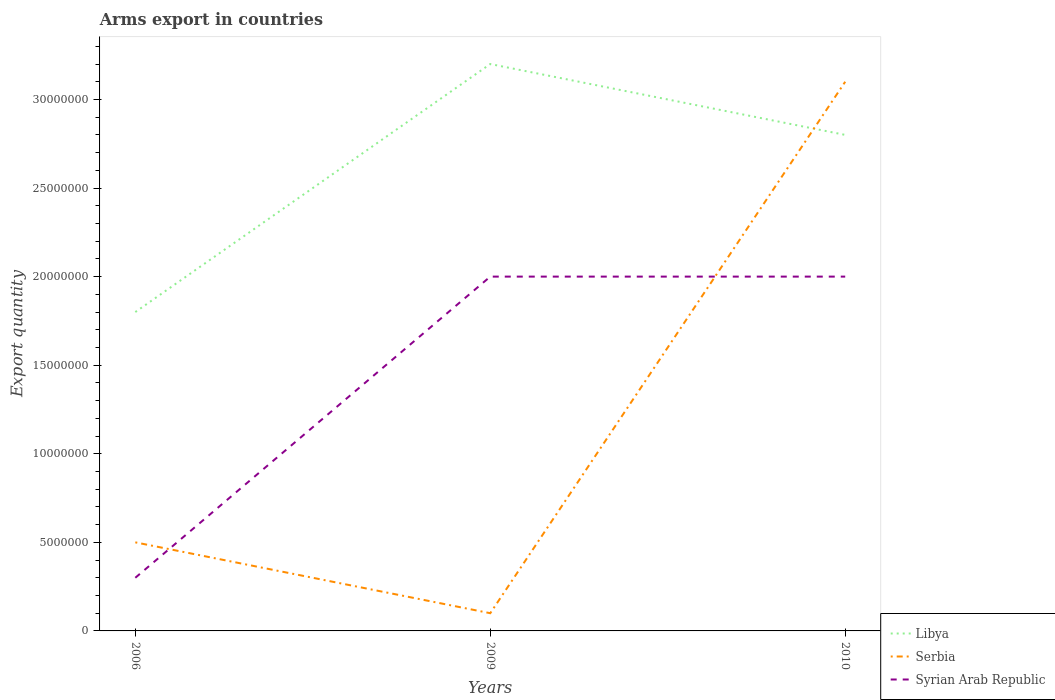Across all years, what is the maximum total arms export in Syrian Arab Republic?
Your answer should be very brief. 3.00e+06. What is the total total arms export in Libya in the graph?
Give a very brief answer. -1.40e+07. What is the difference between the highest and the second highest total arms export in Libya?
Give a very brief answer. 1.40e+07. What is the difference between the highest and the lowest total arms export in Libya?
Give a very brief answer. 2. How many lines are there?
Your answer should be very brief. 3. How many years are there in the graph?
Provide a succinct answer. 3. Are the values on the major ticks of Y-axis written in scientific E-notation?
Your answer should be compact. No. Does the graph contain grids?
Give a very brief answer. No. How many legend labels are there?
Offer a terse response. 3. How are the legend labels stacked?
Provide a succinct answer. Vertical. What is the title of the graph?
Give a very brief answer. Arms export in countries. What is the label or title of the X-axis?
Your response must be concise. Years. What is the label or title of the Y-axis?
Your answer should be compact. Export quantity. What is the Export quantity of Libya in 2006?
Offer a terse response. 1.80e+07. What is the Export quantity in Serbia in 2006?
Your answer should be compact. 5.00e+06. What is the Export quantity of Syrian Arab Republic in 2006?
Give a very brief answer. 3.00e+06. What is the Export quantity in Libya in 2009?
Your answer should be very brief. 3.20e+07. What is the Export quantity in Libya in 2010?
Provide a short and direct response. 2.80e+07. What is the Export quantity in Serbia in 2010?
Offer a terse response. 3.10e+07. Across all years, what is the maximum Export quantity in Libya?
Keep it short and to the point. 3.20e+07. Across all years, what is the maximum Export quantity in Serbia?
Keep it short and to the point. 3.10e+07. Across all years, what is the maximum Export quantity in Syrian Arab Republic?
Offer a terse response. 2.00e+07. Across all years, what is the minimum Export quantity of Libya?
Ensure brevity in your answer.  1.80e+07. What is the total Export quantity of Libya in the graph?
Your answer should be very brief. 7.80e+07. What is the total Export quantity of Serbia in the graph?
Make the answer very short. 3.70e+07. What is the total Export quantity in Syrian Arab Republic in the graph?
Give a very brief answer. 4.30e+07. What is the difference between the Export quantity of Libya in 2006 and that in 2009?
Keep it short and to the point. -1.40e+07. What is the difference between the Export quantity in Serbia in 2006 and that in 2009?
Ensure brevity in your answer.  4.00e+06. What is the difference between the Export quantity of Syrian Arab Republic in 2006 and that in 2009?
Make the answer very short. -1.70e+07. What is the difference between the Export quantity of Libya in 2006 and that in 2010?
Your answer should be very brief. -1.00e+07. What is the difference between the Export quantity in Serbia in 2006 and that in 2010?
Offer a terse response. -2.60e+07. What is the difference between the Export quantity of Syrian Arab Republic in 2006 and that in 2010?
Offer a terse response. -1.70e+07. What is the difference between the Export quantity of Libya in 2009 and that in 2010?
Keep it short and to the point. 4.00e+06. What is the difference between the Export quantity of Serbia in 2009 and that in 2010?
Provide a succinct answer. -3.00e+07. What is the difference between the Export quantity in Syrian Arab Republic in 2009 and that in 2010?
Your answer should be very brief. 0. What is the difference between the Export quantity of Libya in 2006 and the Export quantity of Serbia in 2009?
Make the answer very short. 1.70e+07. What is the difference between the Export quantity in Libya in 2006 and the Export quantity in Syrian Arab Republic in 2009?
Make the answer very short. -2.00e+06. What is the difference between the Export quantity of Serbia in 2006 and the Export quantity of Syrian Arab Republic in 2009?
Offer a very short reply. -1.50e+07. What is the difference between the Export quantity in Libya in 2006 and the Export quantity in Serbia in 2010?
Your answer should be very brief. -1.30e+07. What is the difference between the Export quantity in Serbia in 2006 and the Export quantity in Syrian Arab Republic in 2010?
Offer a very short reply. -1.50e+07. What is the difference between the Export quantity of Serbia in 2009 and the Export quantity of Syrian Arab Republic in 2010?
Offer a terse response. -1.90e+07. What is the average Export quantity of Libya per year?
Keep it short and to the point. 2.60e+07. What is the average Export quantity in Serbia per year?
Give a very brief answer. 1.23e+07. What is the average Export quantity in Syrian Arab Republic per year?
Offer a terse response. 1.43e+07. In the year 2006, what is the difference between the Export quantity of Libya and Export quantity of Serbia?
Provide a succinct answer. 1.30e+07. In the year 2006, what is the difference between the Export quantity of Libya and Export quantity of Syrian Arab Republic?
Your answer should be compact. 1.50e+07. In the year 2006, what is the difference between the Export quantity of Serbia and Export quantity of Syrian Arab Republic?
Your answer should be very brief. 2.00e+06. In the year 2009, what is the difference between the Export quantity of Libya and Export quantity of Serbia?
Make the answer very short. 3.10e+07. In the year 2009, what is the difference between the Export quantity of Serbia and Export quantity of Syrian Arab Republic?
Ensure brevity in your answer.  -1.90e+07. In the year 2010, what is the difference between the Export quantity of Serbia and Export quantity of Syrian Arab Republic?
Make the answer very short. 1.10e+07. What is the ratio of the Export quantity of Libya in 2006 to that in 2009?
Provide a short and direct response. 0.56. What is the ratio of the Export quantity of Serbia in 2006 to that in 2009?
Ensure brevity in your answer.  5. What is the ratio of the Export quantity of Libya in 2006 to that in 2010?
Ensure brevity in your answer.  0.64. What is the ratio of the Export quantity in Serbia in 2006 to that in 2010?
Your answer should be compact. 0.16. What is the ratio of the Export quantity of Serbia in 2009 to that in 2010?
Your answer should be very brief. 0.03. What is the difference between the highest and the second highest Export quantity of Libya?
Give a very brief answer. 4.00e+06. What is the difference between the highest and the second highest Export quantity in Serbia?
Ensure brevity in your answer.  2.60e+07. What is the difference between the highest and the lowest Export quantity in Libya?
Make the answer very short. 1.40e+07. What is the difference between the highest and the lowest Export quantity in Serbia?
Make the answer very short. 3.00e+07. What is the difference between the highest and the lowest Export quantity in Syrian Arab Republic?
Your response must be concise. 1.70e+07. 